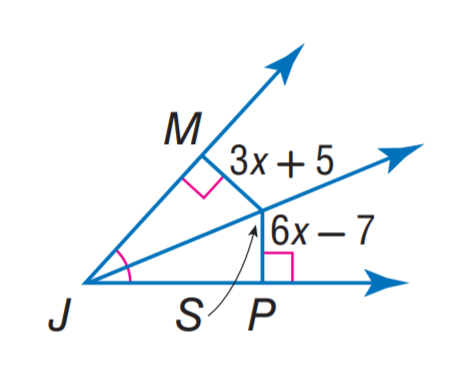Question: Find S P.
Choices:
A. 5
B. 6
C. 7
D. 17
Answer with the letter. Answer: D 